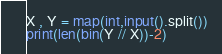<code> <loc_0><loc_0><loc_500><loc_500><_Python_>X , Y = map(int,input().split())
print(len(bin(Y // X))-2)</code> 